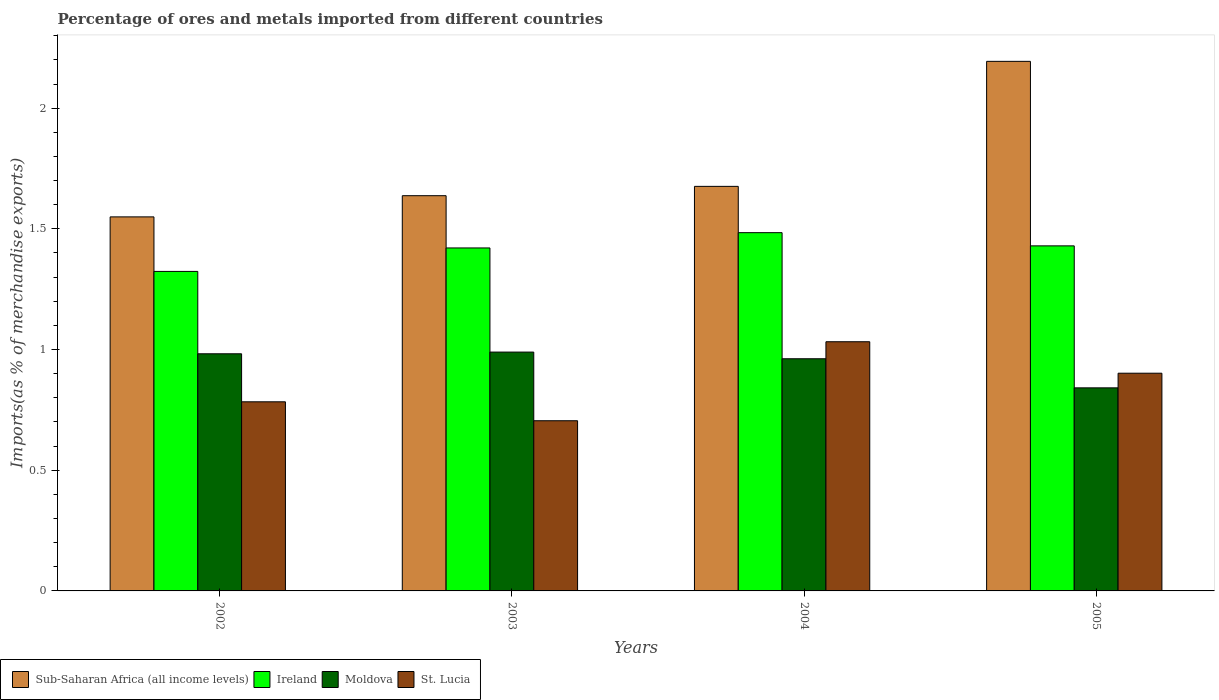How many different coloured bars are there?
Ensure brevity in your answer.  4. Are the number of bars per tick equal to the number of legend labels?
Offer a very short reply. Yes. What is the label of the 3rd group of bars from the left?
Offer a terse response. 2004. In how many cases, is the number of bars for a given year not equal to the number of legend labels?
Give a very brief answer. 0. What is the percentage of imports to different countries in Moldova in 2005?
Your answer should be compact. 0.84. Across all years, what is the maximum percentage of imports to different countries in Sub-Saharan Africa (all income levels)?
Offer a very short reply. 2.19. Across all years, what is the minimum percentage of imports to different countries in Sub-Saharan Africa (all income levels)?
Your answer should be very brief. 1.55. In which year was the percentage of imports to different countries in St. Lucia maximum?
Provide a short and direct response. 2004. What is the total percentage of imports to different countries in Sub-Saharan Africa (all income levels) in the graph?
Offer a terse response. 7.06. What is the difference between the percentage of imports to different countries in St. Lucia in 2004 and that in 2005?
Make the answer very short. 0.13. What is the difference between the percentage of imports to different countries in Moldova in 2002 and the percentage of imports to different countries in Ireland in 2004?
Give a very brief answer. -0.5. What is the average percentage of imports to different countries in Moldova per year?
Offer a terse response. 0.94. In the year 2005, what is the difference between the percentage of imports to different countries in Sub-Saharan Africa (all income levels) and percentage of imports to different countries in Moldova?
Give a very brief answer. 1.35. What is the ratio of the percentage of imports to different countries in St. Lucia in 2003 to that in 2005?
Your answer should be compact. 0.78. What is the difference between the highest and the second highest percentage of imports to different countries in Moldova?
Provide a short and direct response. 0.01. What is the difference between the highest and the lowest percentage of imports to different countries in Moldova?
Your response must be concise. 0.15. Is the sum of the percentage of imports to different countries in St. Lucia in 2004 and 2005 greater than the maximum percentage of imports to different countries in Sub-Saharan Africa (all income levels) across all years?
Keep it short and to the point. No. What does the 4th bar from the left in 2002 represents?
Your answer should be very brief. St. Lucia. What does the 3rd bar from the right in 2002 represents?
Offer a terse response. Ireland. How many bars are there?
Make the answer very short. 16. How many years are there in the graph?
Offer a terse response. 4. Are the values on the major ticks of Y-axis written in scientific E-notation?
Give a very brief answer. No. Does the graph contain grids?
Keep it short and to the point. No. How many legend labels are there?
Your answer should be very brief. 4. What is the title of the graph?
Provide a short and direct response. Percentage of ores and metals imported from different countries. What is the label or title of the Y-axis?
Your response must be concise. Imports(as % of merchandise exports). What is the Imports(as % of merchandise exports) of Sub-Saharan Africa (all income levels) in 2002?
Provide a short and direct response. 1.55. What is the Imports(as % of merchandise exports) of Ireland in 2002?
Provide a succinct answer. 1.32. What is the Imports(as % of merchandise exports) of Moldova in 2002?
Offer a terse response. 0.98. What is the Imports(as % of merchandise exports) of St. Lucia in 2002?
Ensure brevity in your answer.  0.78. What is the Imports(as % of merchandise exports) of Sub-Saharan Africa (all income levels) in 2003?
Ensure brevity in your answer.  1.64. What is the Imports(as % of merchandise exports) in Ireland in 2003?
Give a very brief answer. 1.42. What is the Imports(as % of merchandise exports) in Moldova in 2003?
Provide a short and direct response. 0.99. What is the Imports(as % of merchandise exports) in St. Lucia in 2003?
Your answer should be very brief. 0.71. What is the Imports(as % of merchandise exports) of Sub-Saharan Africa (all income levels) in 2004?
Provide a short and direct response. 1.68. What is the Imports(as % of merchandise exports) in Ireland in 2004?
Keep it short and to the point. 1.48. What is the Imports(as % of merchandise exports) in Moldova in 2004?
Your response must be concise. 0.96. What is the Imports(as % of merchandise exports) in St. Lucia in 2004?
Ensure brevity in your answer.  1.03. What is the Imports(as % of merchandise exports) of Sub-Saharan Africa (all income levels) in 2005?
Your response must be concise. 2.19. What is the Imports(as % of merchandise exports) in Ireland in 2005?
Your answer should be compact. 1.43. What is the Imports(as % of merchandise exports) in Moldova in 2005?
Give a very brief answer. 0.84. What is the Imports(as % of merchandise exports) of St. Lucia in 2005?
Make the answer very short. 0.9. Across all years, what is the maximum Imports(as % of merchandise exports) of Sub-Saharan Africa (all income levels)?
Keep it short and to the point. 2.19. Across all years, what is the maximum Imports(as % of merchandise exports) of Ireland?
Provide a succinct answer. 1.48. Across all years, what is the maximum Imports(as % of merchandise exports) in Moldova?
Your response must be concise. 0.99. Across all years, what is the maximum Imports(as % of merchandise exports) in St. Lucia?
Your response must be concise. 1.03. Across all years, what is the minimum Imports(as % of merchandise exports) in Sub-Saharan Africa (all income levels)?
Ensure brevity in your answer.  1.55. Across all years, what is the minimum Imports(as % of merchandise exports) in Ireland?
Provide a succinct answer. 1.32. Across all years, what is the minimum Imports(as % of merchandise exports) of Moldova?
Offer a terse response. 0.84. Across all years, what is the minimum Imports(as % of merchandise exports) of St. Lucia?
Keep it short and to the point. 0.71. What is the total Imports(as % of merchandise exports) in Sub-Saharan Africa (all income levels) in the graph?
Offer a terse response. 7.06. What is the total Imports(as % of merchandise exports) in Ireland in the graph?
Offer a very short reply. 5.66. What is the total Imports(as % of merchandise exports) of Moldova in the graph?
Keep it short and to the point. 3.77. What is the total Imports(as % of merchandise exports) in St. Lucia in the graph?
Provide a short and direct response. 3.42. What is the difference between the Imports(as % of merchandise exports) of Sub-Saharan Africa (all income levels) in 2002 and that in 2003?
Give a very brief answer. -0.09. What is the difference between the Imports(as % of merchandise exports) in Ireland in 2002 and that in 2003?
Make the answer very short. -0.1. What is the difference between the Imports(as % of merchandise exports) in Moldova in 2002 and that in 2003?
Your response must be concise. -0.01. What is the difference between the Imports(as % of merchandise exports) in St. Lucia in 2002 and that in 2003?
Your answer should be compact. 0.08. What is the difference between the Imports(as % of merchandise exports) of Sub-Saharan Africa (all income levels) in 2002 and that in 2004?
Your answer should be compact. -0.13. What is the difference between the Imports(as % of merchandise exports) of Ireland in 2002 and that in 2004?
Your answer should be compact. -0.16. What is the difference between the Imports(as % of merchandise exports) in Moldova in 2002 and that in 2004?
Offer a very short reply. 0.02. What is the difference between the Imports(as % of merchandise exports) of St. Lucia in 2002 and that in 2004?
Offer a terse response. -0.25. What is the difference between the Imports(as % of merchandise exports) in Sub-Saharan Africa (all income levels) in 2002 and that in 2005?
Offer a very short reply. -0.64. What is the difference between the Imports(as % of merchandise exports) in Ireland in 2002 and that in 2005?
Keep it short and to the point. -0.11. What is the difference between the Imports(as % of merchandise exports) of Moldova in 2002 and that in 2005?
Offer a very short reply. 0.14. What is the difference between the Imports(as % of merchandise exports) of St. Lucia in 2002 and that in 2005?
Your answer should be compact. -0.12. What is the difference between the Imports(as % of merchandise exports) of Sub-Saharan Africa (all income levels) in 2003 and that in 2004?
Provide a succinct answer. -0.04. What is the difference between the Imports(as % of merchandise exports) of Ireland in 2003 and that in 2004?
Provide a succinct answer. -0.06. What is the difference between the Imports(as % of merchandise exports) of Moldova in 2003 and that in 2004?
Provide a succinct answer. 0.03. What is the difference between the Imports(as % of merchandise exports) of St. Lucia in 2003 and that in 2004?
Make the answer very short. -0.33. What is the difference between the Imports(as % of merchandise exports) in Sub-Saharan Africa (all income levels) in 2003 and that in 2005?
Offer a very short reply. -0.56. What is the difference between the Imports(as % of merchandise exports) of Ireland in 2003 and that in 2005?
Provide a short and direct response. -0.01. What is the difference between the Imports(as % of merchandise exports) in Moldova in 2003 and that in 2005?
Your response must be concise. 0.15. What is the difference between the Imports(as % of merchandise exports) in St. Lucia in 2003 and that in 2005?
Make the answer very short. -0.2. What is the difference between the Imports(as % of merchandise exports) of Sub-Saharan Africa (all income levels) in 2004 and that in 2005?
Give a very brief answer. -0.52. What is the difference between the Imports(as % of merchandise exports) in Ireland in 2004 and that in 2005?
Offer a terse response. 0.05. What is the difference between the Imports(as % of merchandise exports) of Moldova in 2004 and that in 2005?
Offer a very short reply. 0.12. What is the difference between the Imports(as % of merchandise exports) in St. Lucia in 2004 and that in 2005?
Your response must be concise. 0.13. What is the difference between the Imports(as % of merchandise exports) in Sub-Saharan Africa (all income levels) in 2002 and the Imports(as % of merchandise exports) in Ireland in 2003?
Keep it short and to the point. 0.13. What is the difference between the Imports(as % of merchandise exports) in Sub-Saharan Africa (all income levels) in 2002 and the Imports(as % of merchandise exports) in Moldova in 2003?
Provide a succinct answer. 0.56. What is the difference between the Imports(as % of merchandise exports) of Sub-Saharan Africa (all income levels) in 2002 and the Imports(as % of merchandise exports) of St. Lucia in 2003?
Your answer should be compact. 0.84. What is the difference between the Imports(as % of merchandise exports) in Ireland in 2002 and the Imports(as % of merchandise exports) in Moldova in 2003?
Provide a succinct answer. 0.33. What is the difference between the Imports(as % of merchandise exports) of Ireland in 2002 and the Imports(as % of merchandise exports) of St. Lucia in 2003?
Keep it short and to the point. 0.62. What is the difference between the Imports(as % of merchandise exports) of Moldova in 2002 and the Imports(as % of merchandise exports) of St. Lucia in 2003?
Provide a short and direct response. 0.28. What is the difference between the Imports(as % of merchandise exports) of Sub-Saharan Africa (all income levels) in 2002 and the Imports(as % of merchandise exports) of Ireland in 2004?
Offer a very short reply. 0.07. What is the difference between the Imports(as % of merchandise exports) of Sub-Saharan Africa (all income levels) in 2002 and the Imports(as % of merchandise exports) of Moldova in 2004?
Your answer should be very brief. 0.59. What is the difference between the Imports(as % of merchandise exports) of Sub-Saharan Africa (all income levels) in 2002 and the Imports(as % of merchandise exports) of St. Lucia in 2004?
Provide a short and direct response. 0.52. What is the difference between the Imports(as % of merchandise exports) of Ireland in 2002 and the Imports(as % of merchandise exports) of Moldova in 2004?
Your answer should be compact. 0.36. What is the difference between the Imports(as % of merchandise exports) of Ireland in 2002 and the Imports(as % of merchandise exports) of St. Lucia in 2004?
Provide a succinct answer. 0.29. What is the difference between the Imports(as % of merchandise exports) in Sub-Saharan Africa (all income levels) in 2002 and the Imports(as % of merchandise exports) in Ireland in 2005?
Your response must be concise. 0.12. What is the difference between the Imports(as % of merchandise exports) of Sub-Saharan Africa (all income levels) in 2002 and the Imports(as % of merchandise exports) of Moldova in 2005?
Offer a terse response. 0.71. What is the difference between the Imports(as % of merchandise exports) in Sub-Saharan Africa (all income levels) in 2002 and the Imports(as % of merchandise exports) in St. Lucia in 2005?
Offer a very short reply. 0.65. What is the difference between the Imports(as % of merchandise exports) in Ireland in 2002 and the Imports(as % of merchandise exports) in Moldova in 2005?
Make the answer very short. 0.48. What is the difference between the Imports(as % of merchandise exports) in Ireland in 2002 and the Imports(as % of merchandise exports) in St. Lucia in 2005?
Ensure brevity in your answer.  0.42. What is the difference between the Imports(as % of merchandise exports) in Moldova in 2002 and the Imports(as % of merchandise exports) in St. Lucia in 2005?
Your response must be concise. 0.08. What is the difference between the Imports(as % of merchandise exports) in Sub-Saharan Africa (all income levels) in 2003 and the Imports(as % of merchandise exports) in Ireland in 2004?
Ensure brevity in your answer.  0.15. What is the difference between the Imports(as % of merchandise exports) of Sub-Saharan Africa (all income levels) in 2003 and the Imports(as % of merchandise exports) of Moldova in 2004?
Give a very brief answer. 0.68. What is the difference between the Imports(as % of merchandise exports) in Sub-Saharan Africa (all income levels) in 2003 and the Imports(as % of merchandise exports) in St. Lucia in 2004?
Give a very brief answer. 0.6. What is the difference between the Imports(as % of merchandise exports) in Ireland in 2003 and the Imports(as % of merchandise exports) in Moldova in 2004?
Provide a short and direct response. 0.46. What is the difference between the Imports(as % of merchandise exports) in Ireland in 2003 and the Imports(as % of merchandise exports) in St. Lucia in 2004?
Ensure brevity in your answer.  0.39. What is the difference between the Imports(as % of merchandise exports) of Moldova in 2003 and the Imports(as % of merchandise exports) of St. Lucia in 2004?
Your response must be concise. -0.04. What is the difference between the Imports(as % of merchandise exports) of Sub-Saharan Africa (all income levels) in 2003 and the Imports(as % of merchandise exports) of Ireland in 2005?
Offer a very short reply. 0.21. What is the difference between the Imports(as % of merchandise exports) in Sub-Saharan Africa (all income levels) in 2003 and the Imports(as % of merchandise exports) in Moldova in 2005?
Your answer should be compact. 0.8. What is the difference between the Imports(as % of merchandise exports) in Sub-Saharan Africa (all income levels) in 2003 and the Imports(as % of merchandise exports) in St. Lucia in 2005?
Your response must be concise. 0.74. What is the difference between the Imports(as % of merchandise exports) in Ireland in 2003 and the Imports(as % of merchandise exports) in Moldova in 2005?
Your answer should be compact. 0.58. What is the difference between the Imports(as % of merchandise exports) in Ireland in 2003 and the Imports(as % of merchandise exports) in St. Lucia in 2005?
Your answer should be compact. 0.52. What is the difference between the Imports(as % of merchandise exports) in Moldova in 2003 and the Imports(as % of merchandise exports) in St. Lucia in 2005?
Your answer should be compact. 0.09. What is the difference between the Imports(as % of merchandise exports) of Sub-Saharan Africa (all income levels) in 2004 and the Imports(as % of merchandise exports) of Ireland in 2005?
Provide a succinct answer. 0.25. What is the difference between the Imports(as % of merchandise exports) of Sub-Saharan Africa (all income levels) in 2004 and the Imports(as % of merchandise exports) of Moldova in 2005?
Provide a short and direct response. 0.83. What is the difference between the Imports(as % of merchandise exports) in Sub-Saharan Africa (all income levels) in 2004 and the Imports(as % of merchandise exports) in St. Lucia in 2005?
Keep it short and to the point. 0.77. What is the difference between the Imports(as % of merchandise exports) of Ireland in 2004 and the Imports(as % of merchandise exports) of Moldova in 2005?
Provide a succinct answer. 0.64. What is the difference between the Imports(as % of merchandise exports) in Ireland in 2004 and the Imports(as % of merchandise exports) in St. Lucia in 2005?
Ensure brevity in your answer.  0.58. What is the difference between the Imports(as % of merchandise exports) in Moldova in 2004 and the Imports(as % of merchandise exports) in St. Lucia in 2005?
Give a very brief answer. 0.06. What is the average Imports(as % of merchandise exports) of Sub-Saharan Africa (all income levels) per year?
Provide a succinct answer. 1.76. What is the average Imports(as % of merchandise exports) of Ireland per year?
Offer a terse response. 1.41. What is the average Imports(as % of merchandise exports) of Moldova per year?
Your answer should be very brief. 0.94. What is the average Imports(as % of merchandise exports) of St. Lucia per year?
Your answer should be very brief. 0.86. In the year 2002, what is the difference between the Imports(as % of merchandise exports) of Sub-Saharan Africa (all income levels) and Imports(as % of merchandise exports) of Ireland?
Your response must be concise. 0.23. In the year 2002, what is the difference between the Imports(as % of merchandise exports) of Sub-Saharan Africa (all income levels) and Imports(as % of merchandise exports) of Moldova?
Your answer should be compact. 0.57. In the year 2002, what is the difference between the Imports(as % of merchandise exports) of Sub-Saharan Africa (all income levels) and Imports(as % of merchandise exports) of St. Lucia?
Provide a short and direct response. 0.77. In the year 2002, what is the difference between the Imports(as % of merchandise exports) in Ireland and Imports(as % of merchandise exports) in Moldova?
Your response must be concise. 0.34. In the year 2002, what is the difference between the Imports(as % of merchandise exports) of Ireland and Imports(as % of merchandise exports) of St. Lucia?
Your response must be concise. 0.54. In the year 2002, what is the difference between the Imports(as % of merchandise exports) of Moldova and Imports(as % of merchandise exports) of St. Lucia?
Provide a short and direct response. 0.2. In the year 2003, what is the difference between the Imports(as % of merchandise exports) of Sub-Saharan Africa (all income levels) and Imports(as % of merchandise exports) of Ireland?
Provide a succinct answer. 0.22. In the year 2003, what is the difference between the Imports(as % of merchandise exports) of Sub-Saharan Africa (all income levels) and Imports(as % of merchandise exports) of Moldova?
Ensure brevity in your answer.  0.65. In the year 2003, what is the difference between the Imports(as % of merchandise exports) in Sub-Saharan Africa (all income levels) and Imports(as % of merchandise exports) in St. Lucia?
Offer a terse response. 0.93. In the year 2003, what is the difference between the Imports(as % of merchandise exports) of Ireland and Imports(as % of merchandise exports) of Moldova?
Provide a succinct answer. 0.43. In the year 2003, what is the difference between the Imports(as % of merchandise exports) in Ireland and Imports(as % of merchandise exports) in St. Lucia?
Your answer should be very brief. 0.72. In the year 2003, what is the difference between the Imports(as % of merchandise exports) in Moldova and Imports(as % of merchandise exports) in St. Lucia?
Offer a very short reply. 0.28. In the year 2004, what is the difference between the Imports(as % of merchandise exports) in Sub-Saharan Africa (all income levels) and Imports(as % of merchandise exports) in Ireland?
Offer a terse response. 0.19. In the year 2004, what is the difference between the Imports(as % of merchandise exports) in Sub-Saharan Africa (all income levels) and Imports(as % of merchandise exports) in Moldova?
Make the answer very short. 0.71. In the year 2004, what is the difference between the Imports(as % of merchandise exports) in Sub-Saharan Africa (all income levels) and Imports(as % of merchandise exports) in St. Lucia?
Provide a short and direct response. 0.64. In the year 2004, what is the difference between the Imports(as % of merchandise exports) of Ireland and Imports(as % of merchandise exports) of Moldova?
Give a very brief answer. 0.52. In the year 2004, what is the difference between the Imports(as % of merchandise exports) of Ireland and Imports(as % of merchandise exports) of St. Lucia?
Keep it short and to the point. 0.45. In the year 2004, what is the difference between the Imports(as % of merchandise exports) of Moldova and Imports(as % of merchandise exports) of St. Lucia?
Make the answer very short. -0.07. In the year 2005, what is the difference between the Imports(as % of merchandise exports) of Sub-Saharan Africa (all income levels) and Imports(as % of merchandise exports) of Ireland?
Keep it short and to the point. 0.76. In the year 2005, what is the difference between the Imports(as % of merchandise exports) in Sub-Saharan Africa (all income levels) and Imports(as % of merchandise exports) in Moldova?
Offer a terse response. 1.35. In the year 2005, what is the difference between the Imports(as % of merchandise exports) in Sub-Saharan Africa (all income levels) and Imports(as % of merchandise exports) in St. Lucia?
Ensure brevity in your answer.  1.29. In the year 2005, what is the difference between the Imports(as % of merchandise exports) of Ireland and Imports(as % of merchandise exports) of Moldova?
Your answer should be very brief. 0.59. In the year 2005, what is the difference between the Imports(as % of merchandise exports) in Ireland and Imports(as % of merchandise exports) in St. Lucia?
Give a very brief answer. 0.53. In the year 2005, what is the difference between the Imports(as % of merchandise exports) in Moldova and Imports(as % of merchandise exports) in St. Lucia?
Your answer should be very brief. -0.06. What is the ratio of the Imports(as % of merchandise exports) in Sub-Saharan Africa (all income levels) in 2002 to that in 2003?
Give a very brief answer. 0.95. What is the ratio of the Imports(as % of merchandise exports) in Ireland in 2002 to that in 2003?
Offer a very short reply. 0.93. What is the ratio of the Imports(as % of merchandise exports) of Moldova in 2002 to that in 2003?
Offer a terse response. 0.99. What is the ratio of the Imports(as % of merchandise exports) in St. Lucia in 2002 to that in 2003?
Ensure brevity in your answer.  1.11. What is the ratio of the Imports(as % of merchandise exports) of Sub-Saharan Africa (all income levels) in 2002 to that in 2004?
Provide a succinct answer. 0.92. What is the ratio of the Imports(as % of merchandise exports) in Ireland in 2002 to that in 2004?
Make the answer very short. 0.89. What is the ratio of the Imports(as % of merchandise exports) of Moldova in 2002 to that in 2004?
Your answer should be compact. 1.02. What is the ratio of the Imports(as % of merchandise exports) in St. Lucia in 2002 to that in 2004?
Offer a terse response. 0.76. What is the ratio of the Imports(as % of merchandise exports) in Sub-Saharan Africa (all income levels) in 2002 to that in 2005?
Make the answer very short. 0.71. What is the ratio of the Imports(as % of merchandise exports) of Ireland in 2002 to that in 2005?
Ensure brevity in your answer.  0.93. What is the ratio of the Imports(as % of merchandise exports) in Moldova in 2002 to that in 2005?
Ensure brevity in your answer.  1.17. What is the ratio of the Imports(as % of merchandise exports) of St. Lucia in 2002 to that in 2005?
Offer a very short reply. 0.87. What is the ratio of the Imports(as % of merchandise exports) of Sub-Saharan Africa (all income levels) in 2003 to that in 2004?
Offer a terse response. 0.98. What is the ratio of the Imports(as % of merchandise exports) in Ireland in 2003 to that in 2004?
Ensure brevity in your answer.  0.96. What is the ratio of the Imports(as % of merchandise exports) of Moldova in 2003 to that in 2004?
Your answer should be very brief. 1.03. What is the ratio of the Imports(as % of merchandise exports) of St. Lucia in 2003 to that in 2004?
Make the answer very short. 0.68. What is the ratio of the Imports(as % of merchandise exports) in Sub-Saharan Africa (all income levels) in 2003 to that in 2005?
Offer a very short reply. 0.75. What is the ratio of the Imports(as % of merchandise exports) in Ireland in 2003 to that in 2005?
Provide a short and direct response. 0.99. What is the ratio of the Imports(as % of merchandise exports) in Moldova in 2003 to that in 2005?
Offer a very short reply. 1.18. What is the ratio of the Imports(as % of merchandise exports) in St. Lucia in 2003 to that in 2005?
Provide a short and direct response. 0.78. What is the ratio of the Imports(as % of merchandise exports) of Sub-Saharan Africa (all income levels) in 2004 to that in 2005?
Offer a terse response. 0.76. What is the ratio of the Imports(as % of merchandise exports) of Ireland in 2004 to that in 2005?
Your answer should be very brief. 1.04. What is the ratio of the Imports(as % of merchandise exports) of Moldova in 2004 to that in 2005?
Provide a succinct answer. 1.14. What is the ratio of the Imports(as % of merchandise exports) of St. Lucia in 2004 to that in 2005?
Offer a terse response. 1.14. What is the difference between the highest and the second highest Imports(as % of merchandise exports) of Sub-Saharan Africa (all income levels)?
Ensure brevity in your answer.  0.52. What is the difference between the highest and the second highest Imports(as % of merchandise exports) of Ireland?
Offer a terse response. 0.05. What is the difference between the highest and the second highest Imports(as % of merchandise exports) in Moldova?
Provide a short and direct response. 0.01. What is the difference between the highest and the second highest Imports(as % of merchandise exports) of St. Lucia?
Make the answer very short. 0.13. What is the difference between the highest and the lowest Imports(as % of merchandise exports) of Sub-Saharan Africa (all income levels)?
Make the answer very short. 0.64. What is the difference between the highest and the lowest Imports(as % of merchandise exports) of Ireland?
Your response must be concise. 0.16. What is the difference between the highest and the lowest Imports(as % of merchandise exports) in Moldova?
Make the answer very short. 0.15. What is the difference between the highest and the lowest Imports(as % of merchandise exports) of St. Lucia?
Keep it short and to the point. 0.33. 